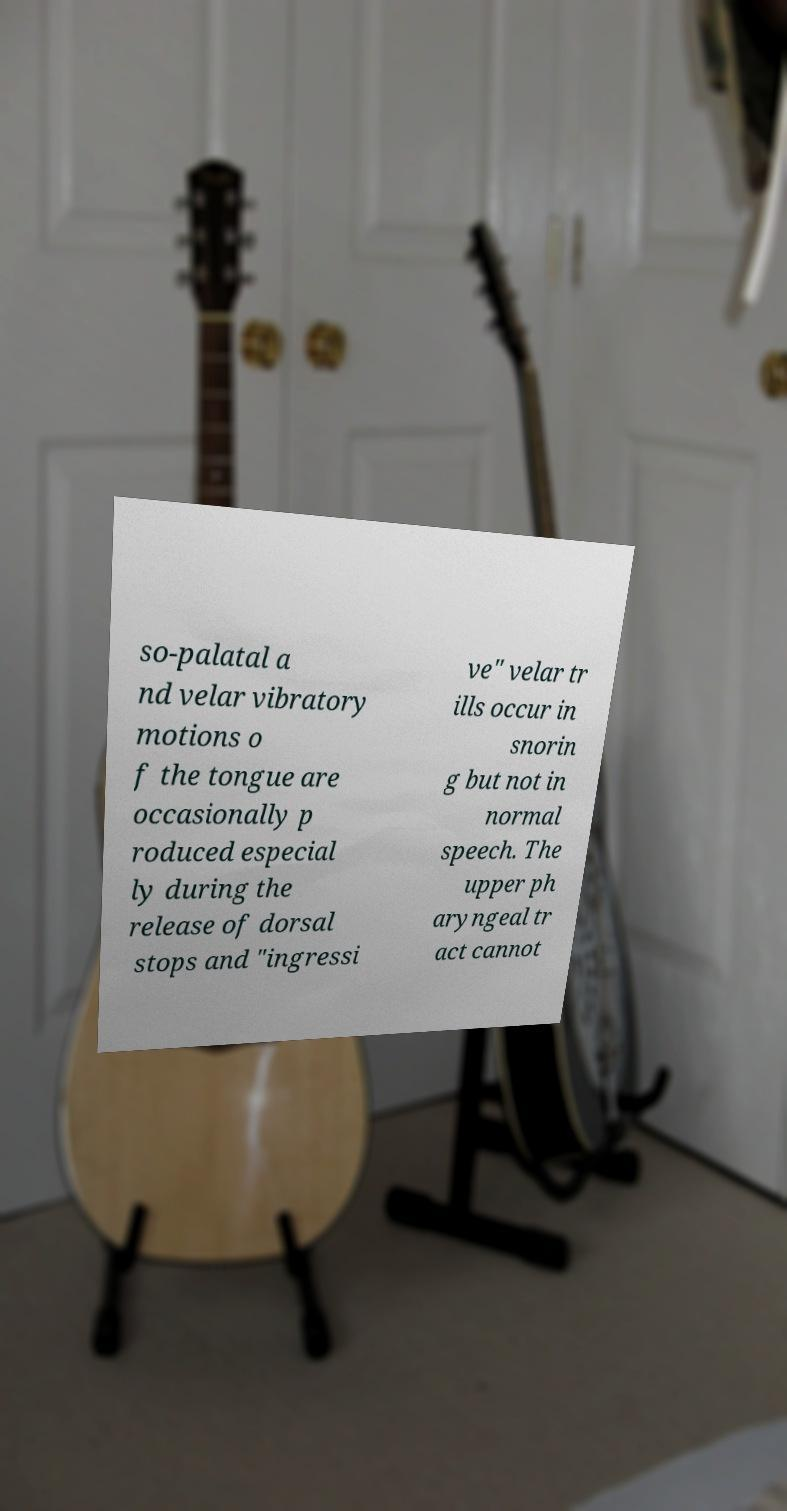I need the written content from this picture converted into text. Can you do that? so-palatal a nd velar vibratory motions o f the tongue are occasionally p roduced especial ly during the release of dorsal stops and "ingressi ve" velar tr ills occur in snorin g but not in normal speech. The upper ph aryngeal tr act cannot 